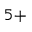Convert formula to latex. <formula><loc_0><loc_0><loc_500><loc_500>^ { 5 + }</formula> 